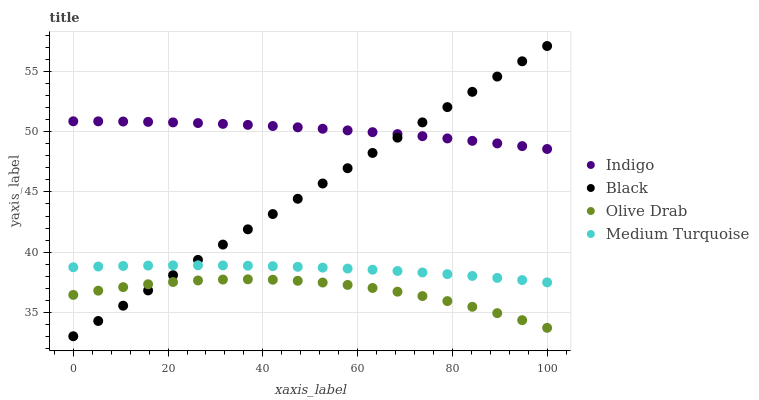Does Olive Drab have the minimum area under the curve?
Answer yes or no. Yes. Does Indigo have the maximum area under the curve?
Answer yes or no. Yes. Does Medium Turquoise have the minimum area under the curve?
Answer yes or no. No. Does Medium Turquoise have the maximum area under the curve?
Answer yes or no. No. Is Black the smoothest?
Answer yes or no. Yes. Is Olive Drab the roughest?
Answer yes or no. Yes. Is Indigo the smoothest?
Answer yes or no. No. Is Indigo the roughest?
Answer yes or no. No. Does Black have the lowest value?
Answer yes or no. Yes. Does Medium Turquoise have the lowest value?
Answer yes or no. No. Does Black have the highest value?
Answer yes or no. Yes. Does Indigo have the highest value?
Answer yes or no. No. Is Olive Drab less than Medium Turquoise?
Answer yes or no. Yes. Is Indigo greater than Medium Turquoise?
Answer yes or no. Yes. Does Black intersect Medium Turquoise?
Answer yes or no. Yes. Is Black less than Medium Turquoise?
Answer yes or no. No. Is Black greater than Medium Turquoise?
Answer yes or no. No. Does Olive Drab intersect Medium Turquoise?
Answer yes or no. No. 